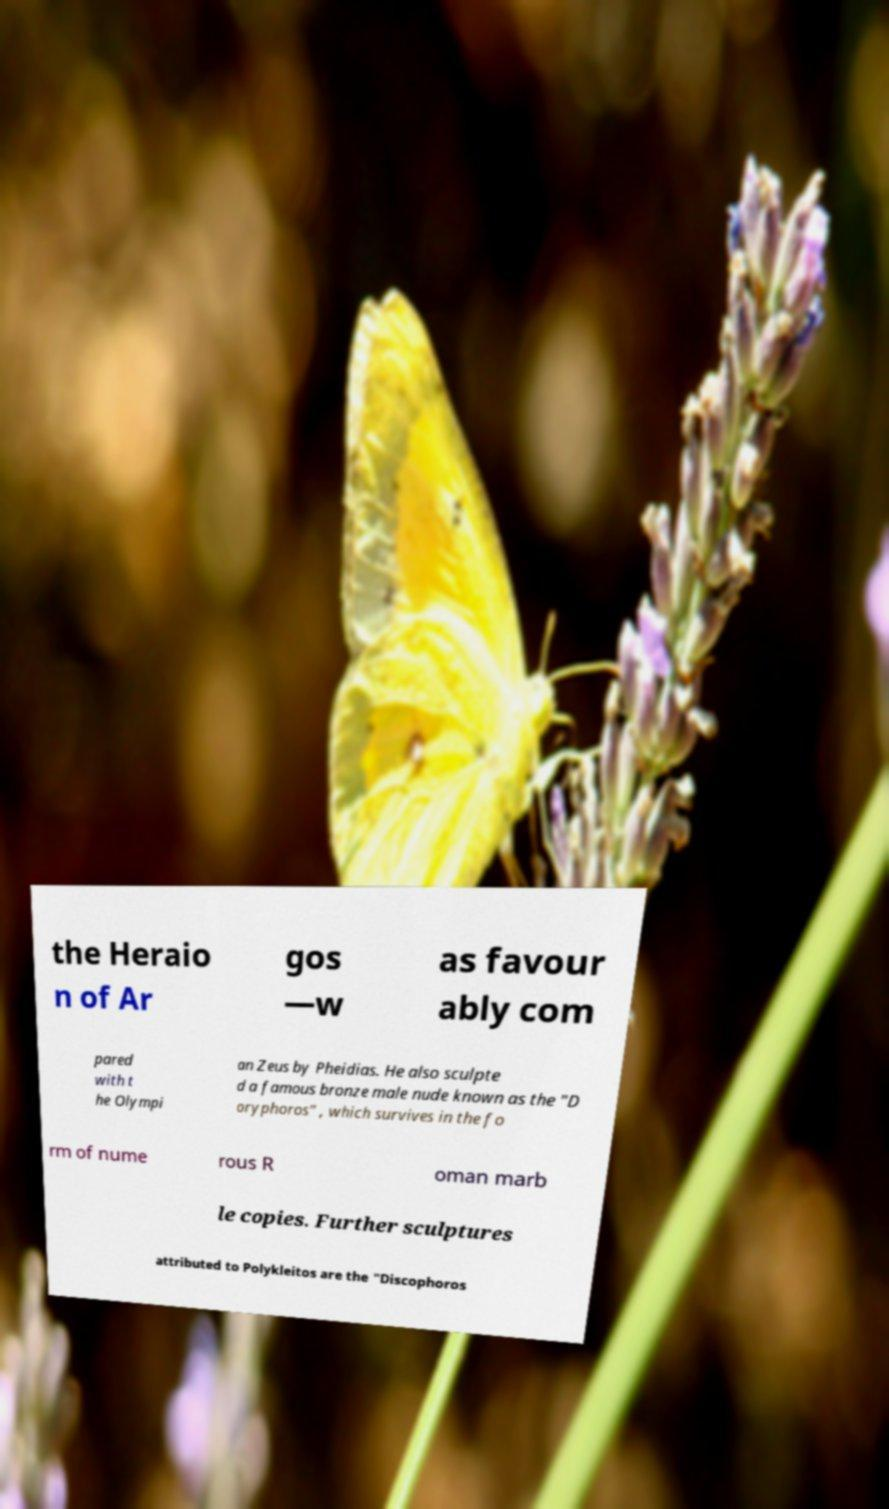Can you accurately transcribe the text from the provided image for me? the Heraio n of Ar gos —w as favour ably com pared with t he Olympi an Zeus by Pheidias. He also sculpte d a famous bronze male nude known as the "D oryphoros" , which survives in the fo rm of nume rous R oman marb le copies. Further sculptures attributed to Polykleitos are the "Discophoros 